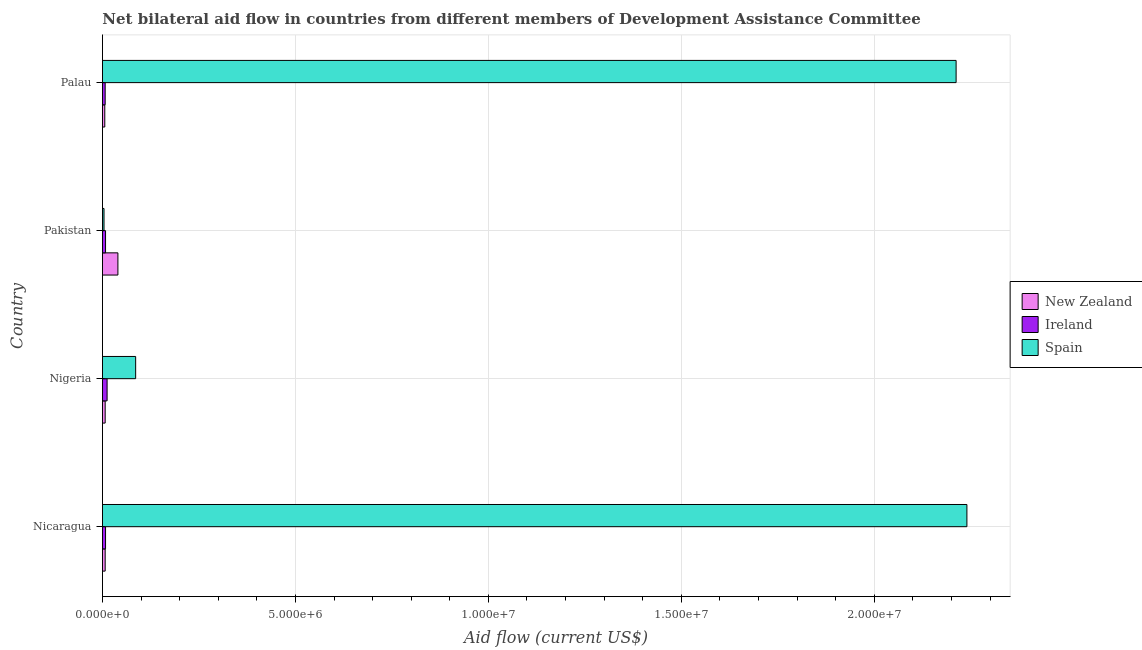Are the number of bars per tick equal to the number of legend labels?
Your answer should be very brief. Yes. How many bars are there on the 1st tick from the top?
Give a very brief answer. 3. How many bars are there on the 2nd tick from the bottom?
Provide a short and direct response. 3. What is the amount of aid provided by spain in Nigeria?
Your response must be concise. 8.60e+05. Across all countries, what is the maximum amount of aid provided by new zealand?
Your answer should be compact. 4.00e+05. Across all countries, what is the minimum amount of aid provided by ireland?
Make the answer very short. 7.00e+04. In which country was the amount of aid provided by spain maximum?
Ensure brevity in your answer.  Nicaragua. In which country was the amount of aid provided by new zealand minimum?
Keep it short and to the point. Palau. What is the total amount of aid provided by spain in the graph?
Keep it short and to the point. 4.54e+07. What is the difference between the amount of aid provided by new zealand in Nigeria and that in Palau?
Ensure brevity in your answer.  10000. What is the difference between the amount of aid provided by new zealand in Nigeria and the amount of aid provided by spain in Palau?
Provide a short and direct response. -2.20e+07. What is the average amount of aid provided by ireland per country?
Keep it short and to the point. 8.75e+04. What is the difference between the amount of aid provided by ireland and amount of aid provided by spain in Nicaragua?
Keep it short and to the point. -2.23e+07. In how many countries, is the amount of aid provided by ireland greater than 20000000 US$?
Provide a succinct answer. 0. What is the difference between the highest and the second highest amount of aid provided by ireland?
Your answer should be very brief. 4.00e+04. What is the difference between the highest and the lowest amount of aid provided by spain?
Give a very brief answer. 2.24e+07. Is the sum of the amount of aid provided by new zealand in Nicaragua and Nigeria greater than the maximum amount of aid provided by spain across all countries?
Give a very brief answer. No. What does the 2nd bar from the top in Pakistan represents?
Make the answer very short. Ireland. What does the 1st bar from the bottom in Palau represents?
Provide a short and direct response. New Zealand. Is it the case that in every country, the sum of the amount of aid provided by new zealand and amount of aid provided by ireland is greater than the amount of aid provided by spain?
Provide a succinct answer. No. How many bars are there?
Make the answer very short. 12. What is the difference between two consecutive major ticks on the X-axis?
Your response must be concise. 5.00e+06. Does the graph contain grids?
Your answer should be compact. Yes. How many legend labels are there?
Give a very brief answer. 3. What is the title of the graph?
Make the answer very short. Net bilateral aid flow in countries from different members of Development Assistance Committee. What is the label or title of the X-axis?
Provide a short and direct response. Aid flow (current US$). What is the label or title of the Y-axis?
Keep it short and to the point. Country. What is the Aid flow (current US$) of New Zealand in Nicaragua?
Ensure brevity in your answer.  7.00e+04. What is the Aid flow (current US$) of Ireland in Nicaragua?
Keep it short and to the point. 8.00e+04. What is the Aid flow (current US$) of Spain in Nicaragua?
Provide a succinct answer. 2.24e+07. What is the Aid flow (current US$) of New Zealand in Nigeria?
Make the answer very short. 7.00e+04. What is the Aid flow (current US$) in Spain in Nigeria?
Your response must be concise. 8.60e+05. What is the Aid flow (current US$) of Ireland in Pakistan?
Your answer should be very brief. 8.00e+04. What is the Aid flow (current US$) of New Zealand in Palau?
Give a very brief answer. 6.00e+04. What is the Aid flow (current US$) of Ireland in Palau?
Provide a short and direct response. 7.00e+04. What is the Aid flow (current US$) in Spain in Palau?
Ensure brevity in your answer.  2.21e+07. Across all countries, what is the maximum Aid flow (current US$) of New Zealand?
Provide a short and direct response. 4.00e+05. Across all countries, what is the maximum Aid flow (current US$) in Ireland?
Your response must be concise. 1.20e+05. Across all countries, what is the maximum Aid flow (current US$) of Spain?
Provide a succinct answer. 2.24e+07. Across all countries, what is the minimum Aid flow (current US$) in New Zealand?
Provide a succinct answer. 6.00e+04. Across all countries, what is the minimum Aid flow (current US$) in Ireland?
Your response must be concise. 7.00e+04. Across all countries, what is the minimum Aid flow (current US$) of Spain?
Make the answer very short. 4.00e+04. What is the total Aid flow (current US$) of Spain in the graph?
Your answer should be compact. 4.54e+07. What is the difference between the Aid flow (current US$) in Ireland in Nicaragua and that in Nigeria?
Your answer should be compact. -4.00e+04. What is the difference between the Aid flow (current US$) in Spain in Nicaragua and that in Nigeria?
Offer a very short reply. 2.15e+07. What is the difference between the Aid flow (current US$) of New Zealand in Nicaragua and that in Pakistan?
Your answer should be compact. -3.30e+05. What is the difference between the Aid flow (current US$) in Ireland in Nicaragua and that in Pakistan?
Give a very brief answer. 0. What is the difference between the Aid flow (current US$) in Spain in Nicaragua and that in Pakistan?
Your response must be concise. 2.24e+07. What is the difference between the Aid flow (current US$) in New Zealand in Nicaragua and that in Palau?
Ensure brevity in your answer.  10000. What is the difference between the Aid flow (current US$) in Ireland in Nicaragua and that in Palau?
Offer a terse response. 10000. What is the difference between the Aid flow (current US$) in Spain in Nicaragua and that in Palau?
Offer a very short reply. 2.80e+05. What is the difference between the Aid flow (current US$) of New Zealand in Nigeria and that in Pakistan?
Give a very brief answer. -3.30e+05. What is the difference between the Aid flow (current US$) in Ireland in Nigeria and that in Pakistan?
Your answer should be compact. 4.00e+04. What is the difference between the Aid flow (current US$) in Spain in Nigeria and that in Pakistan?
Your answer should be compact. 8.20e+05. What is the difference between the Aid flow (current US$) in New Zealand in Nigeria and that in Palau?
Offer a terse response. 10000. What is the difference between the Aid flow (current US$) in Ireland in Nigeria and that in Palau?
Your response must be concise. 5.00e+04. What is the difference between the Aid flow (current US$) of Spain in Nigeria and that in Palau?
Ensure brevity in your answer.  -2.13e+07. What is the difference between the Aid flow (current US$) in New Zealand in Pakistan and that in Palau?
Keep it short and to the point. 3.40e+05. What is the difference between the Aid flow (current US$) of Spain in Pakistan and that in Palau?
Offer a very short reply. -2.21e+07. What is the difference between the Aid flow (current US$) in New Zealand in Nicaragua and the Aid flow (current US$) in Ireland in Nigeria?
Your answer should be compact. -5.00e+04. What is the difference between the Aid flow (current US$) in New Zealand in Nicaragua and the Aid flow (current US$) in Spain in Nigeria?
Provide a short and direct response. -7.90e+05. What is the difference between the Aid flow (current US$) of Ireland in Nicaragua and the Aid flow (current US$) of Spain in Nigeria?
Your answer should be compact. -7.80e+05. What is the difference between the Aid flow (current US$) of Ireland in Nicaragua and the Aid flow (current US$) of Spain in Pakistan?
Provide a succinct answer. 4.00e+04. What is the difference between the Aid flow (current US$) of New Zealand in Nicaragua and the Aid flow (current US$) of Ireland in Palau?
Your answer should be compact. 0. What is the difference between the Aid flow (current US$) in New Zealand in Nicaragua and the Aid flow (current US$) in Spain in Palau?
Offer a terse response. -2.20e+07. What is the difference between the Aid flow (current US$) in Ireland in Nicaragua and the Aid flow (current US$) in Spain in Palau?
Provide a short and direct response. -2.20e+07. What is the difference between the Aid flow (current US$) of New Zealand in Nigeria and the Aid flow (current US$) of Ireland in Pakistan?
Make the answer very short. -10000. What is the difference between the Aid flow (current US$) of New Zealand in Nigeria and the Aid flow (current US$) of Spain in Palau?
Make the answer very short. -2.20e+07. What is the difference between the Aid flow (current US$) of Ireland in Nigeria and the Aid flow (current US$) of Spain in Palau?
Your answer should be compact. -2.20e+07. What is the difference between the Aid flow (current US$) in New Zealand in Pakistan and the Aid flow (current US$) in Spain in Palau?
Provide a short and direct response. -2.17e+07. What is the difference between the Aid flow (current US$) in Ireland in Pakistan and the Aid flow (current US$) in Spain in Palau?
Give a very brief answer. -2.20e+07. What is the average Aid flow (current US$) in Ireland per country?
Ensure brevity in your answer.  8.75e+04. What is the average Aid flow (current US$) in Spain per country?
Provide a succinct answer. 1.14e+07. What is the difference between the Aid flow (current US$) in New Zealand and Aid flow (current US$) in Ireland in Nicaragua?
Ensure brevity in your answer.  -10000. What is the difference between the Aid flow (current US$) in New Zealand and Aid flow (current US$) in Spain in Nicaragua?
Provide a short and direct response. -2.23e+07. What is the difference between the Aid flow (current US$) of Ireland and Aid flow (current US$) of Spain in Nicaragua?
Offer a very short reply. -2.23e+07. What is the difference between the Aid flow (current US$) of New Zealand and Aid flow (current US$) of Ireland in Nigeria?
Ensure brevity in your answer.  -5.00e+04. What is the difference between the Aid flow (current US$) of New Zealand and Aid flow (current US$) of Spain in Nigeria?
Keep it short and to the point. -7.90e+05. What is the difference between the Aid flow (current US$) in Ireland and Aid flow (current US$) in Spain in Nigeria?
Make the answer very short. -7.40e+05. What is the difference between the Aid flow (current US$) of New Zealand and Aid flow (current US$) of Ireland in Pakistan?
Make the answer very short. 3.20e+05. What is the difference between the Aid flow (current US$) in New Zealand and Aid flow (current US$) in Ireland in Palau?
Give a very brief answer. -10000. What is the difference between the Aid flow (current US$) of New Zealand and Aid flow (current US$) of Spain in Palau?
Give a very brief answer. -2.21e+07. What is the difference between the Aid flow (current US$) of Ireland and Aid flow (current US$) of Spain in Palau?
Provide a succinct answer. -2.20e+07. What is the ratio of the Aid flow (current US$) of Ireland in Nicaragua to that in Nigeria?
Keep it short and to the point. 0.67. What is the ratio of the Aid flow (current US$) of Spain in Nicaragua to that in Nigeria?
Ensure brevity in your answer.  26.05. What is the ratio of the Aid flow (current US$) of New Zealand in Nicaragua to that in Pakistan?
Make the answer very short. 0.17. What is the ratio of the Aid flow (current US$) in Spain in Nicaragua to that in Pakistan?
Provide a succinct answer. 560. What is the ratio of the Aid flow (current US$) of Ireland in Nicaragua to that in Palau?
Give a very brief answer. 1.14. What is the ratio of the Aid flow (current US$) of Spain in Nicaragua to that in Palau?
Offer a very short reply. 1.01. What is the ratio of the Aid flow (current US$) of New Zealand in Nigeria to that in Pakistan?
Your response must be concise. 0.17. What is the ratio of the Aid flow (current US$) of New Zealand in Nigeria to that in Palau?
Keep it short and to the point. 1.17. What is the ratio of the Aid flow (current US$) of Ireland in Nigeria to that in Palau?
Your response must be concise. 1.71. What is the ratio of the Aid flow (current US$) in Spain in Nigeria to that in Palau?
Provide a short and direct response. 0.04. What is the ratio of the Aid flow (current US$) of Spain in Pakistan to that in Palau?
Keep it short and to the point. 0. What is the difference between the highest and the second highest Aid flow (current US$) of New Zealand?
Your response must be concise. 3.30e+05. What is the difference between the highest and the second highest Aid flow (current US$) of Ireland?
Your response must be concise. 4.00e+04. What is the difference between the highest and the lowest Aid flow (current US$) in Ireland?
Ensure brevity in your answer.  5.00e+04. What is the difference between the highest and the lowest Aid flow (current US$) of Spain?
Offer a terse response. 2.24e+07. 